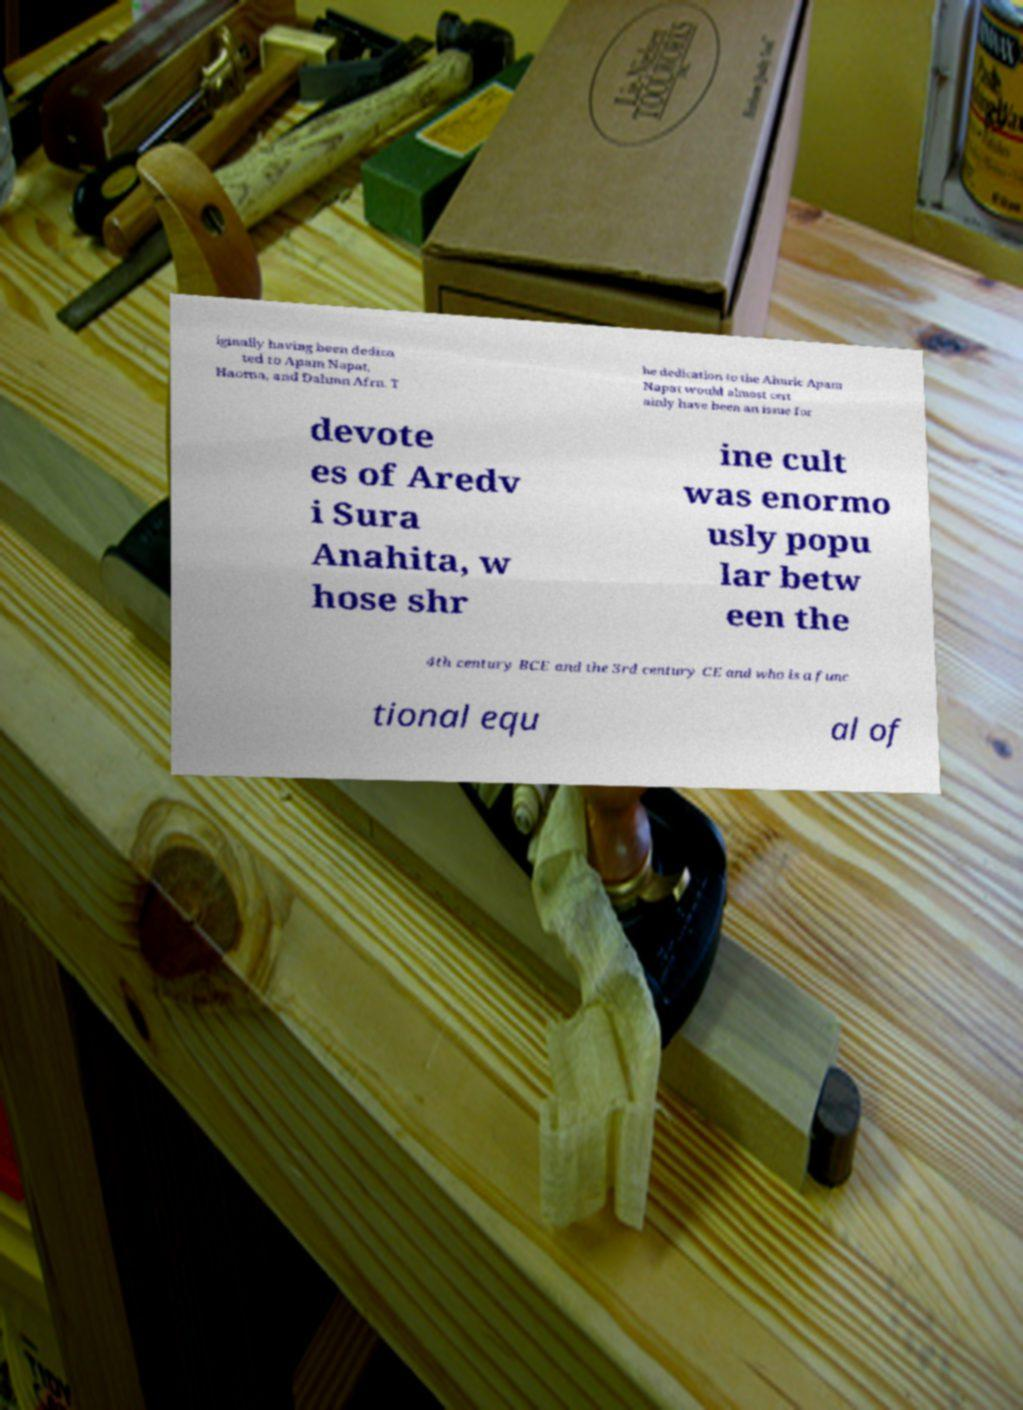There's text embedded in this image that I need extracted. Can you transcribe it verbatim? iginally having been dedica ted to Apam Napat, Haoma, and Dahmn Afrn. T he dedication to the Ahuric Apam Napat would almost cert ainly have been an issue for devote es of Aredv i Sura Anahita, w hose shr ine cult was enormo usly popu lar betw een the 4th century BCE and the 3rd century CE and who is a func tional equ al of 